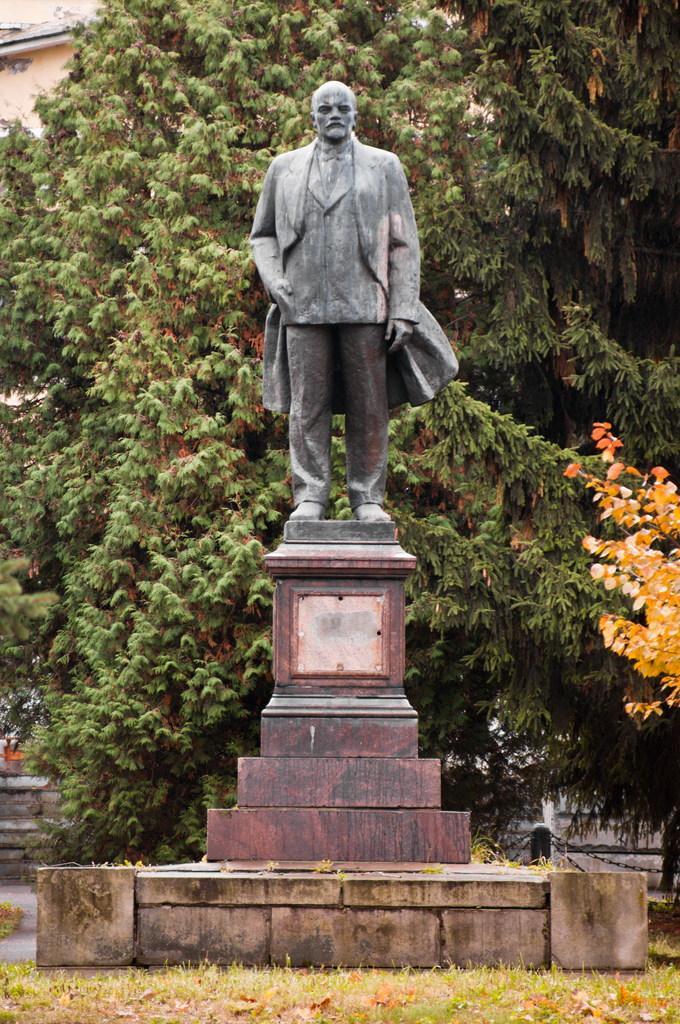Can you describe this image briefly? In this image I can see a statue, seems like a memorial, trees, and building behind the statue. 